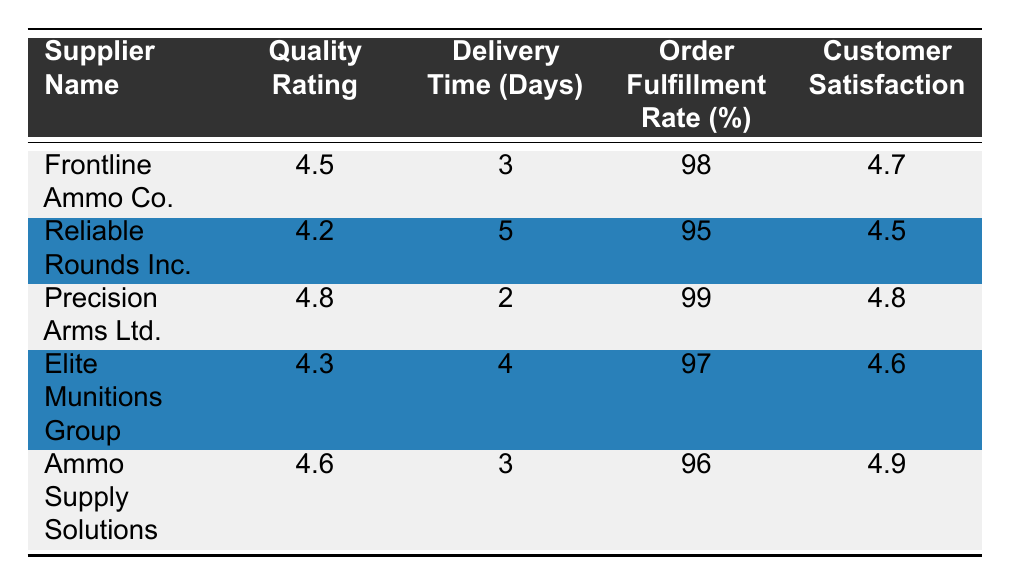What is the quality rating of Precision Arms Ltd.? Looking at the table, the row for Precision Arms Ltd. shows a quality rating of 4.8.
Answer: 4.8 What is the order fulfillment rate of Reliable Rounds Inc.? From the table, the order fulfillment rate for Reliable Rounds Inc. is listed as 95%.
Answer: 95% Which supplier has the lowest delivery time in days? By comparing the delivery times, Precision Arms Ltd. has the lowest delivery time of 2 days.
Answer: Precision Arms Ltd What is the average customer satisfaction score of all suppliers? To find the average, we sum the customer satisfaction scores: (4.7 + 4.5 + 4.8 + 4.6 + 4.9) = 24.5. There are 5 suppliers, so the average is 24.5 / 5 = 4.9.
Answer: 4.9 Is there a supplier with a quality rating higher than 4.7? Yes, Precision Arms Ltd. has a quality rating of 4.8, which is higher than 4.7.
Answer: Yes Which region supplier has the highest order fulfillment rate? Precision Arms Ltd. has the highest order fulfillment rate at 99%, making it the top performer in this category.
Answer: Precision Arms Ltd What is the difference in delivery time between Elite Munitions Group and Ammo Supply Solutions? Elite Munitions Group has a delivery time of 4 days, while Ammo Supply Solutions has 3 days. The difference is 4 - 3 = 1 day.
Answer: 1 day Are all suppliers rated above 4 in quality? Yes, all suppliers listed have quality ratings above 4, with the lowest being 4.2 for Reliable Rounds Inc.
Answer: Yes What is the supplier with the highest customer satisfaction score? Looking at the customer satisfaction scores, Ammo Supply Solutions has the highest score at 4.9.
Answer: Ammo Supply Solutions 